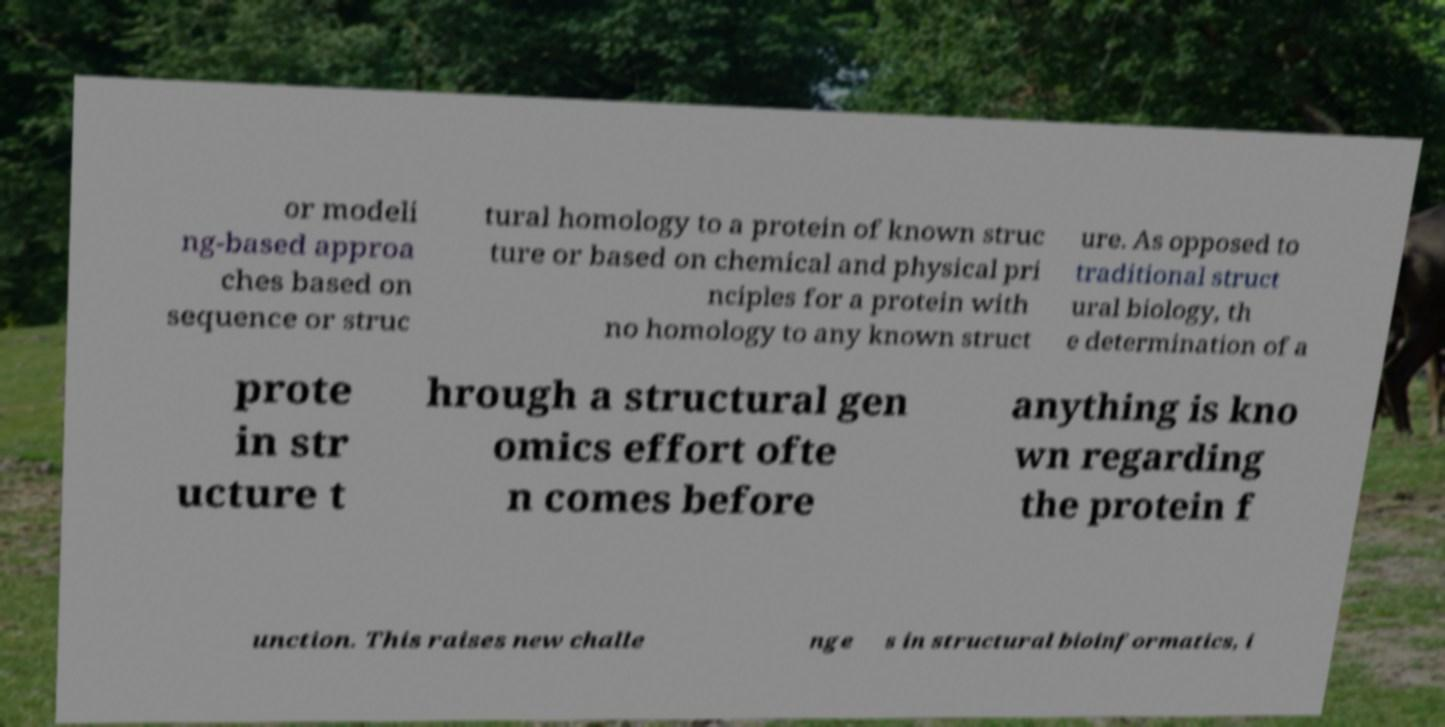I need the written content from this picture converted into text. Can you do that? or modeli ng-based approa ches based on sequence or struc tural homology to a protein of known struc ture or based on chemical and physical pri nciples for a protein with no homology to any known struct ure. As opposed to traditional struct ural biology, th e determination of a prote in str ucture t hrough a structural gen omics effort ofte n comes before anything is kno wn regarding the protein f unction. This raises new challe nge s in structural bioinformatics, i 